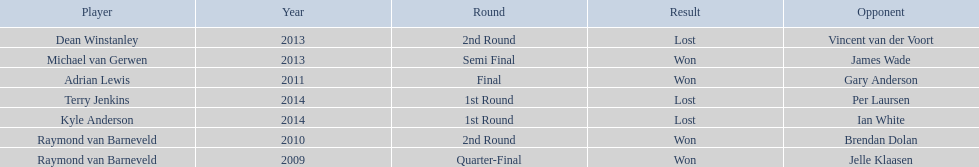Who are all the players? Raymond van Barneveld, Raymond van Barneveld, Adrian Lewis, Dean Winstanley, Michael van Gerwen, Terry Jenkins, Kyle Anderson. When did they play? 2009, 2010, 2011, 2013, 2013, 2014, 2014. And which player played in 2011? Adrian Lewis. 